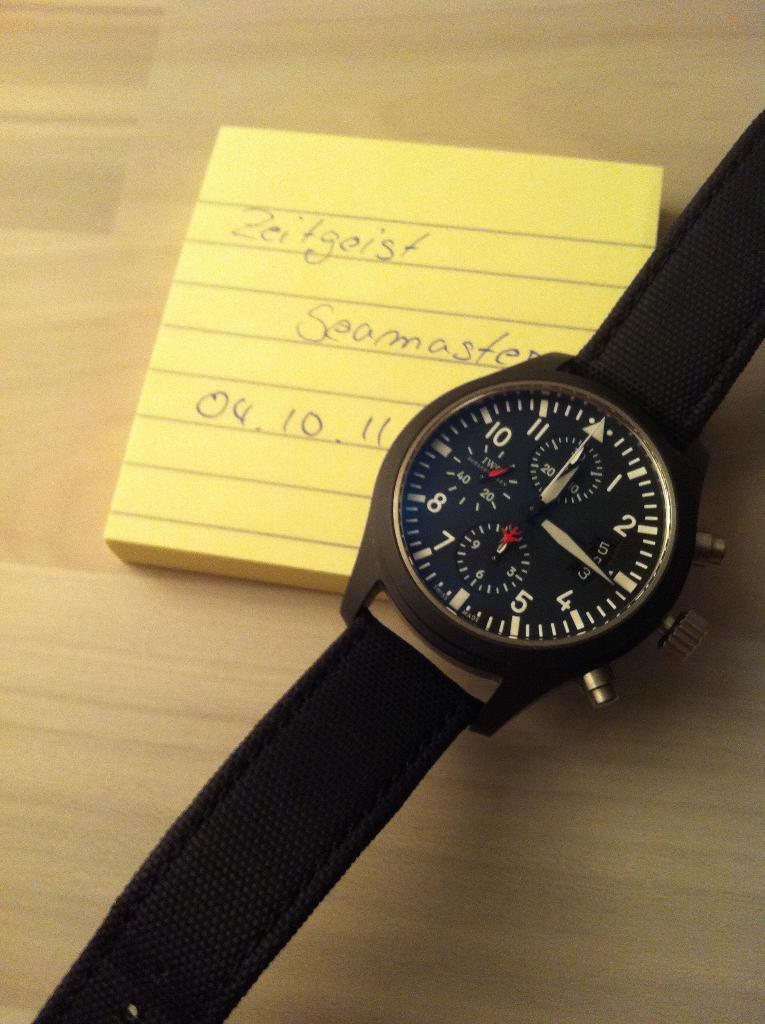<image>
Give a short and clear explanation of the subsequent image. A black wristwatch is on top of a pad of sticky notes that says Zeitgeist on top. 